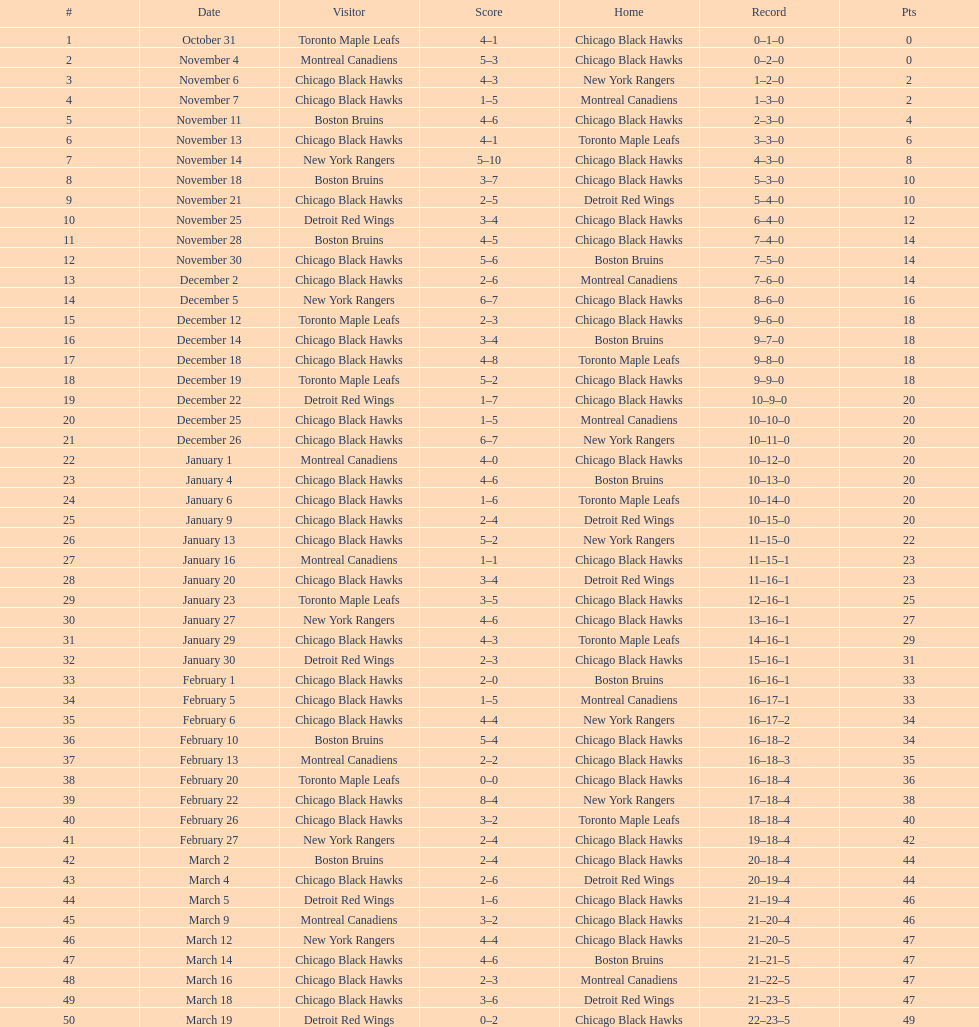Provide the total of points the blackhawks held on march 44. 